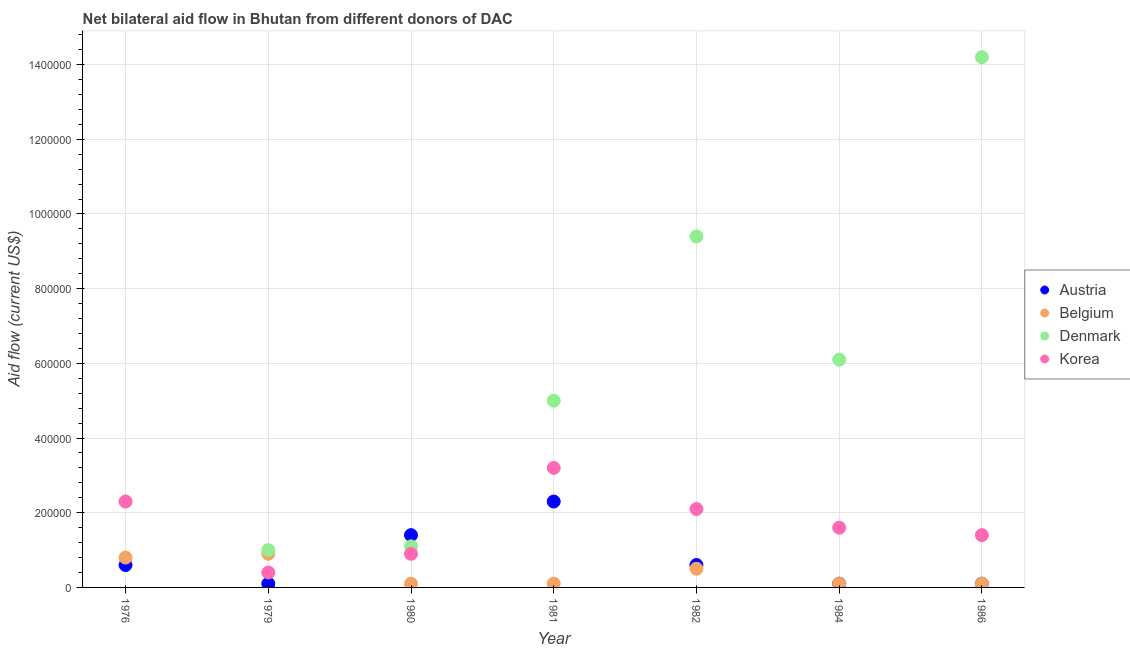How many different coloured dotlines are there?
Keep it short and to the point. 4. What is the amount of aid given by korea in 1984?
Make the answer very short. 1.60e+05. Across all years, what is the maximum amount of aid given by austria?
Give a very brief answer. 2.30e+05. Across all years, what is the minimum amount of aid given by denmark?
Provide a short and direct response. 1.00e+05. In which year was the amount of aid given by denmark maximum?
Give a very brief answer. 1986. In which year was the amount of aid given by korea minimum?
Offer a very short reply. 1979. What is the total amount of aid given by austria in the graph?
Offer a terse response. 5.20e+05. What is the difference between the amount of aid given by korea in 1980 and that in 1986?
Your answer should be very brief. -5.00e+04. What is the difference between the amount of aid given by belgium in 1979 and the amount of aid given by korea in 1984?
Offer a terse response. -7.00e+04. What is the average amount of aid given by belgium per year?
Provide a short and direct response. 3.71e+04. In the year 1986, what is the difference between the amount of aid given by denmark and amount of aid given by belgium?
Give a very brief answer. 1.41e+06. In how many years, is the amount of aid given by austria greater than 1200000 US$?
Ensure brevity in your answer.  0. What is the ratio of the amount of aid given by belgium in 1976 to that in 1979?
Offer a very short reply. 0.89. Is the amount of aid given by korea in 1976 less than that in 1981?
Provide a short and direct response. Yes. What is the difference between the highest and the lowest amount of aid given by denmark?
Your answer should be very brief. 1.32e+06. In how many years, is the amount of aid given by denmark greater than the average amount of aid given by denmark taken over all years?
Offer a terse response. 3. Is the sum of the amount of aid given by denmark in 1976 and 1981 greater than the maximum amount of aid given by korea across all years?
Keep it short and to the point. Yes. Does the amount of aid given by denmark monotonically increase over the years?
Provide a short and direct response. No. Is the amount of aid given by austria strictly greater than the amount of aid given by denmark over the years?
Offer a terse response. No. Is the amount of aid given by austria strictly less than the amount of aid given by korea over the years?
Provide a succinct answer. No. How many dotlines are there?
Your response must be concise. 4. How many years are there in the graph?
Your response must be concise. 7. Does the graph contain any zero values?
Your answer should be very brief. No. Does the graph contain grids?
Provide a short and direct response. Yes. Where does the legend appear in the graph?
Make the answer very short. Center right. What is the title of the graph?
Keep it short and to the point. Net bilateral aid flow in Bhutan from different donors of DAC. Does "Financial sector" appear as one of the legend labels in the graph?
Your response must be concise. No. What is the Aid flow (current US$) in Belgium in 1976?
Give a very brief answer. 8.00e+04. What is the Aid flow (current US$) in Denmark in 1976?
Your response must be concise. 2.30e+05. What is the Aid flow (current US$) in Korea in 1979?
Your response must be concise. 4.00e+04. What is the Aid flow (current US$) of Denmark in 1980?
Ensure brevity in your answer.  1.10e+05. What is the Aid flow (current US$) of Austria in 1981?
Your answer should be compact. 2.30e+05. What is the Aid flow (current US$) in Denmark in 1981?
Provide a short and direct response. 5.00e+05. What is the Aid flow (current US$) of Belgium in 1982?
Your answer should be very brief. 5.00e+04. What is the Aid flow (current US$) of Denmark in 1982?
Make the answer very short. 9.40e+05. What is the Aid flow (current US$) in Korea in 1982?
Ensure brevity in your answer.  2.10e+05. What is the Aid flow (current US$) of Austria in 1984?
Make the answer very short. 10000. What is the Aid flow (current US$) of Belgium in 1986?
Your response must be concise. 10000. What is the Aid flow (current US$) in Denmark in 1986?
Offer a terse response. 1.42e+06. Across all years, what is the maximum Aid flow (current US$) of Belgium?
Your answer should be very brief. 9.00e+04. Across all years, what is the maximum Aid flow (current US$) in Denmark?
Make the answer very short. 1.42e+06. Across all years, what is the maximum Aid flow (current US$) of Korea?
Your answer should be very brief. 3.20e+05. Across all years, what is the minimum Aid flow (current US$) of Korea?
Make the answer very short. 4.00e+04. What is the total Aid flow (current US$) in Austria in the graph?
Offer a very short reply. 5.20e+05. What is the total Aid flow (current US$) of Belgium in the graph?
Your response must be concise. 2.60e+05. What is the total Aid flow (current US$) in Denmark in the graph?
Provide a short and direct response. 3.91e+06. What is the total Aid flow (current US$) in Korea in the graph?
Your answer should be very brief. 1.19e+06. What is the difference between the Aid flow (current US$) of Belgium in 1976 and that in 1980?
Your response must be concise. 7.00e+04. What is the difference between the Aid flow (current US$) of Korea in 1976 and that in 1980?
Give a very brief answer. 1.40e+05. What is the difference between the Aid flow (current US$) in Austria in 1976 and that in 1981?
Offer a terse response. -1.70e+05. What is the difference between the Aid flow (current US$) of Denmark in 1976 and that in 1981?
Ensure brevity in your answer.  -2.70e+05. What is the difference between the Aid flow (current US$) of Denmark in 1976 and that in 1982?
Ensure brevity in your answer.  -7.10e+05. What is the difference between the Aid flow (current US$) in Austria in 1976 and that in 1984?
Provide a short and direct response. 5.00e+04. What is the difference between the Aid flow (current US$) of Belgium in 1976 and that in 1984?
Make the answer very short. 7.00e+04. What is the difference between the Aid flow (current US$) of Denmark in 1976 and that in 1984?
Ensure brevity in your answer.  -3.80e+05. What is the difference between the Aid flow (current US$) of Denmark in 1976 and that in 1986?
Offer a terse response. -1.19e+06. What is the difference between the Aid flow (current US$) of Korea in 1976 and that in 1986?
Give a very brief answer. 9.00e+04. What is the difference between the Aid flow (current US$) of Denmark in 1979 and that in 1980?
Offer a very short reply. -10000. What is the difference between the Aid flow (current US$) in Belgium in 1979 and that in 1981?
Your response must be concise. 8.00e+04. What is the difference between the Aid flow (current US$) of Denmark in 1979 and that in 1981?
Offer a terse response. -4.00e+05. What is the difference between the Aid flow (current US$) of Korea in 1979 and that in 1981?
Provide a succinct answer. -2.80e+05. What is the difference between the Aid flow (current US$) in Denmark in 1979 and that in 1982?
Provide a short and direct response. -8.40e+05. What is the difference between the Aid flow (current US$) in Denmark in 1979 and that in 1984?
Give a very brief answer. -5.10e+05. What is the difference between the Aid flow (current US$) in Korea in 1979 and that in 1984?
Make the answer very short. -1.20e+05. What is the difference between the Aid flow (current US$) of Denmark in 1979 and that in 1986?
Give a very brief answer. -1.32e+06. What is the difference between the Aid flow (current US$) of Korea in 1979 and that in 1986?
Your answer should be compact. -1.00e+05. What is the difference between the Aid flow (current US$) of Austria in 1980 and that in 1981?
Keep it short and to the point. -9.00e+04. What is the difference between the Aid flow (current US$) in Belgium in 1980 and that in 1981?
Your answer should be very brief. 0. What is the difference between the Aid flow (current US$) in Denmark in 1980 and that in 1981?
Make the answer very short. -3.90e+05. What is the difference between the Aid flow (current US$) of Belgium in 1980 and that in 1982?
Your response must be concise. -4.00e+04. What is the difference between the Aid flow (current US$) in Denmark in 1980 and that in 1982?
Provide a short and direct response. -8.30e+05. What is the difference between the Aid flow (current US$) of Austria in 1980 and that in 1984?
Your answer should be very brief. 1.30e+05. What is the difference between the Aid flow (current US$) of Belgium in 1980 and that in 1984?
Provide a succinct answer. 0. What is the difference between the Aid flow (current US$) of Denmark in 1980 and that in 1984?
Offer a very short reply. -5.00e+05. What is the difference between the Aid flow (current US$) in Austria in 1980 and that in 1986?
Keep it short and to the point. 1.30e+05. What is the difference between the Aid flow (current US$) of Belgium in 1980 and that in 1986?
Give a very brief answer. 0. What is the difference between the Aid flow (current US$) in Denmark in 1980 and that in 1986?
Give a very brief answer. -1.31e+06. What is the difference between the Aid flow (current US$) in Belgium in 1981 and that in 1982?
Your response must be concise. -4.00e+04. What is the difference between the Aid flow (current US$) of Denmark in 1981 and that in 1982?
Your answer should be very brief. -4.40e+05. What is the difference between the Aid flow (current US$) of Korea in 1981 and that in 1982?
Offer a terse response. 1.10e+05. What is the difference between the Aid flow (current US$) of Austria in 1981 and that in 1984?
Provide a succinct answer. 2.20e+05. What is the difference between the Aid flow (current US$) of Belgium in 1981 and that in 1984?
Offer a terse response. 0. What is the difference between the Aid flow (current US$) of Denmark in 1981 and that in 1984?
Your answer should be very brief. -1.10e+05. What is the difference between the Aid flow (current US$) in Korea in 1981 and that in 1984?
Offer a terse response. 1.60e+05. What is the difference between the Aid flow (current US$) of Austria in 1981 and that in 1986?
Give a very brief answer. 2.20e+05. What is the difference between the Aid flow (current US$) in Denmark in 1981 and that in 1986?
Provide a short and direct response. -9.20e+05. What is the difference between the Aid flow (current US$) in Korea in 1981 and that in 1986?
Provide a short and direct response. 1.80e+05. What is the difference between the Aid flow (current US$) of Austria in 1982 and that in 1984?
Your answer should be very brief. 5.00e+04. What is the difference between the Aid flow (current US$) of Belgium in 1982 and that in 1984?
Your answer should be compact. 4.00e+04. What is the difference between the Aid flow (current US$) in Denmark in 1982 and that in 1984?
Ensure brevity in your answer.  3.30e+05. What is the difference between the Aid flow (current US$) in Austria in 1982 and that in 1986?
Offer a terse response. 5.00e+04. What is the difference between the Aid flow (current US$) of Belgium in 1982 and that in 1986?
Your answer should be compact. 4.00e+04. What is the difference between the Aid flow (current US$) in Denmark in 1982 and that in 1986?
Your answer should be very brief. -4.80e+05. What is the difference between the Aid flow (current US$) in Korea in 1982 and that in 1986?
Your answer should be compact. 7.00e+04. What is the difference between the Aid flow (current US$) of Belgium in 1984 and that in 1986?
Your answer should be compact. 0. What is the difference between the Aid flow (current US$) in Denmark in 1984 and that in 1986?
Provide a short and direct response. -8.10e+05. What is the difference between the Aid flow (current US$) in Korea in 1984 and that in 1986?
Your answer should be very brief. 2.00e+04. What is the difference between the Aid flow (current US$) in Austria in 1976 and the Aid flow (current US$) in Korea in 1979?
Ensure brevity in your answer.  2.00e+04. What is the difference between the Aid flow (current US$) in Belgium in 1976 and the Aid flow (current US$) in Korea in 1979?
Your response must be concise. 4.00e+04. What is the difference between the Aid flow (current US$) of Denmark in 1976 and the Aid flow (current US$) of Korea in 1979?
Your response must be concise. 1.90e+05. What is the difference between the Aid flow (current US$) in Austria in 1976 and the Aid flow (current US$) in Korea in 1980?
Keep it short and to the point. -3.00e+04. What is the difference between the Aid flow (current US$) in Belgium in 1976 and the Aid flow (current US$) in Denmark in 1980?
Your answer should be very brief. -3.00e+04. What is the difference between the Aid flow (current US$) of Belgium in 1976 and the Aid flow (current US$) of Korea in 1980?
Ensure brevity in your answer.  -10000. What is the difference between the Aid flow (current US$) in Austria in 1976 and the Aid flow (current US$) in Denmark in 1981?
Give a very brief answer. -4.40e+05. What is the difference between the Aid flow (current US$) in Austria in 1976 and the Aid flow (current US$) in Korea in 1981?
Give a very brief answer. -2.60e+05. What is the difference between the Aid flow (current US$) in Belgium in 1976 and the Aid flow (current US$) in Denmark in 1981?
Make the answer very short. -4.20e+05. What is the difference between the Aid flow (current US$) of Austria in 1976 and the Aid flow (current US$) of Belgium in 1982?
Your answer should be compact. 10000. What is the difference between the Aid flow (current US$) in Austria in 1976 and the Aid flow (current US$) in Denmark in 1982?
Your answer should be very brief. -8.80e+05. What is the difference between the Aid flow (current US$) of Belgium in 1976 and the Aid flow (current US$) of Denmark in 1982?
Your response must be concise. -8.60e+05. What is the difference between the Aid flow (current US$) in Belgium in 1976 and the Aid flow (current US$) in Korea in 1982?
Give a very brief answer. -1.30e+05. What is the difference between the Aid flow (current US$) of Austria in 1976 and the Aid flow (current US$) of Denmark in 1984?
Offer a very short reply. -5.50e+05. What is the difference between the Aid flow (current US$) of Belgium in 1976 and the Aid flow (current US$) of Denmark in 1984?
Your answer should be compact. -5.30e+05. What is the difference between the Aid flow (current US$) in Denmark in 1976 and the Aid flow (current US$) in Korea in 1984?
Keep it short and to the point. 7.00e+04. What is the difference between the Aid flow (current US$) in Austria in 1976 and the Aid flow (current US$) in Denmark in 1986?
Offer a terse response. -1.36e+06. What is the difference between the Aid flow (current US$) in Austria in 1976 and the Aid flow (current US$) in Korea in 1986?
Offer a very short reply. -8.00e+04. What is the difference between the Aid flow (current US$) of Belgium in 1976 and the Aid flow (current US$) of Denmark in 1986?
Offer a very short reply. -1.34e+06. What is the difference between the Aid flow (current US$) of Belgium in 1976 and the Aid flow (current US$) of Korea in 1986?
Provide a succinct answer. -6.00e+04. What is the difference between the Aid flow (current US$) in Denmark in 1976 and the Aid flow (current US$) in Korea in 1986?
Give a very brief answer. 9.00e+04. What is the difference between the Aid flow (current US$) of Austria in 1979 and the Aid flow (current US$) of Belgium in 1980?
Keep it short and to the point. 0. What is the difference between the Aid flow (current US$) in Austria in 1979 and the Aid flow (current US$) in Denmark in 1981?
Keep it short and to the point. -4.90e+05. What is the difference between the Aid flow (current US$) in Austria in 1979 and the Aid flow (current US$) in Korea in 1981?
Give a very brief answer. -3.10e+05. What is the difference between the Aid flow (current US$) in Belgium in 1979 and the Aid flow (current US$) in Denmark in 1981?
Provide a succinct answer. -4.10e+05. What is the difference between the Aid flow (current US$) in Belgium in 1979 and the Aid flow (current US$) in Korea in 1981?
Your answer should be compact. -2.30e+05. What is the difference between the Aid flow (current US$) in Austria in 1979 and the Aid flow (current US$) in Denmark in 1982?
Ensure brevity in your answer.  -9.30e+05. What is the difference between the Aid flow (current US$) in Austria in 1979 and the Aid flow (current US$) in Korea in 1982?
Provide a short and direct response. -2.00e+05. What is the difference between the Aid flow (current US$) of Belgium in 1979 and the Aid flow (current US$) of Denmark in 1982?
Offer a very short reply. -8.50e+05. What is the difference between the Aid flow (current US$) of Belgium in 1979 and the Aid flow (current US$) of Korea in 1982?
Offer a very short reply. -1.20e+05. What is the difference between the Aid flow (current US$) of Denmark in 1979 and the Aid flow (current US$) of Korea in 1982?
Offer a terse response. -1.10e+05. What is the difference between the Aid flow (current US$) in Austria in 1979 and the Aid flow (current US$) in Denmark in 1984?
Offer a very short reply. -6.00e+05. What is the difference between the Aid flow (current US$) of Austria in 1979 and the Aid flow (current US$) of Korea in 1984?
Offer a very short reply. -1.50e+05. What is the difference between the Aid flow (current US$) in Belgium in 1979 and the Aid flow (current US$) in Denmark in 1984?
Offer a very short reply. -5.20e+05. What is the difference between the Aid flow (current US$) in Denmark in 1979 and the Aid flow (current US$) in Korea in 1984?
Make the answer very short. -6.00e+04. What is the difference between the Aid flow (current US$) in Austria in 1979 and the Aid flow (current US$) in Belgium in 1986?
Provide a succinct answer. 0. What is the difference between the Aid flow (current US$) in Austria in 1979 and the Aid flow (current US$) in Denmark in 1986?
Ensure brevity in your answer.  -1.41e+06. What is the difference between the Aid flow (current US$) of Austria in 1979 and the Aid flow (current US$) of Korea in 1986?
Your response must be concise. -1.30e+05. What is the difference between the Aid flow (current US$) in Belgium in 1979 and the Aid flow (current US$) in Denmark in 1986?
Provide a short and direct response. -1.33e+06. What is the difference between the Aid flow (current US$) of Belgium in 1979 and the Aid flow (current US$) of Korea in 1986?
Your answer should be compact. -5.00e+04. What is the difference between the Aid flow (current US$) in Austria in 1980 and the Aid flow (current US$) in Denmark in 1981?
Your answer should be very brief. -3.60e+05. What is the difference between the Aid flow (current US$) in Belgium in 1980 and the Aid flow (current US$) in Denmark in 1981?
Your response must be concise. -4.90e+05. What is the difference between the Aid flow (current US$) of Belgium in 1980 and the Aid flow (current US$) of Korea in 1981?
Provide a short and direct response. -3.10e+05. What is the difference between the Aid flow (current US$) in Austria in 1980 and the Aid flow (current US$) in Denmark in 1982?
Provide a short and direct response. -8.00e+05. What is the difference between the Aid flow (current US$) of Austria in 1980 and the Aid flow (current US$) of Korea in 1982?
Keep it short and to the point. -7.00e+04. What is the difference between the Aid flow (current US$) of Belgium in 1980 and the Aid flow (current US$) of Denmark in 1982?
Give a very brief answer. -9.30e+05. What is the difference between the Aid flow (current US$) in Belgium in 1980 and the Aid flow (current US$) in Korea in 1982?
Your response must be concise. -2.00e+05. What is the difference between the Aid flow (current US$) of Denmark in 1980 and the Aid flow (current US$) of Korea in 1982?
Give a very brief answer. -1.00e+05. What is the difference between the Aid flow (current US$) in Austria in 1980 and the Aid flow (current US$) in Denmark in 1984?
Your answer should be very brief. -4.70e+05. What is the difference between the Aid flow (current US$) of Belgium in 1980 and the Aid flow (current US$) of Denmark in 1984?
Your answer should be compact. -6.00e+05. What is the difference between the Aid flow (current US$) of Denmark in 1980 and the Aid flow (current US$) of Korea in 1984?
Offer a terse response. -5.00e+04. What is the difference between the Aid flow (current US$) of Austria in 1980 and the Aid flow (current US$) of Belgium in 1986?
Make the answer very short. 1.30e+05. What is the difference between the Aid flow (current US$) of Austria in 1980 and the Aid flow (current US$) of Denmark in 1986?
Offer a terse response. -1.28e+06. What is the difference between the Aid flow (current US$) in Belgium in 1980 and the Aid flow (current US$) in Denmark in 1986?
Offer a very short reply. -1.41e+06. What is the difference between the Aid flow (current US$) of Belgium in 1980 and the Aid flow (current US$) of Korea in 1986?
Your answer should be very brief. -1.30e+05. What is the difference between the Aid flow (current US$) of Austria in 1981 and the Aid flow (current US$) of Belgium in 1982?
Your answer should be very brief. 1.80e+05. What is the difference between the Aid flow (current US$) of Austria in 1981 and the Aid flow (current US$) of Denmark in 1982?
Provide a short and direct response. -7.10e+05. What is the difference between the Aid flow (current US$) of Austria in 1981 and the Aid flow (current US$) of Korea in 1982?
Offer a terse response. 2.00e+04. What is the difference between the Aid flow (current US$) of Belgium in 1981 and the Aid flow (current US$) of Denmark in 1982?
Keep it short and to the point. -9.30e+05. What is the difference between the Aid flow (current US$) of Belgium in 1981 and the Aid flow (current US$) of Korea in 1982?
Your response must be concise. -2.00e+05. What is the difference between the Aid flow (current US$) in Austria in 1981 and the Aid flow (current US$) in Denmark in 1984?
Make the answer very short. -3.80e+05. What is the difference between the Aid flow (current US$) in Austria in 1981 and the Aid flow (current US$) in Korea in 1984?
Provide a succinct answer. 7.00e+04. What is the difference between the Aid flow (current US$) in Belgium in 1981 and the Aid flow (current US$) in Denmark in 1984?
Ensure brevity in your answer.  -6.00e+05. What is the difference between the Aid flow (current US$) in Belgium in 1981 and the Aid flow (current US$) in Korea in 1984?
Provide a short and direct response. -1.50e+05. What is the difference between the Aid flow (current US$) of Denmark in 1981 and the Aid flow (current US$) of Korea in 1984?
Offer a terse response. 3.40e+05. What is the difference between the Aid flow (current US$) in Austria in 1981 and the Aid flow (current US$) in Denmark in 1986?
Make the answer very short. -1.19e+06. What is the difference between the Aid flow (current US$) of Austria in 1981 and the Aid flow (current US$) of Korea in 1986?
Your answer should be compact. 9.00e+04. What is the difference between the Aid flow (current US$) of Belgium in 1981 and the Aid flow (current US$) of Denmark in 1986?
Offer a terse response. -1.41e+06. What is the difference between the Aid flow (current US$) of Austria in 1982 and the Aid flow (current US$) of Denmark in 1984?
Offer a terse response. -5.50e+05. What is the difference between the Aid flow (current US$) of Belgium in 1982 and the Aid flow (current US$) of Denmark in 1984?
Offer a terse response. -5.60e+05. What is the difference between the Aid flow (current US$) in Belgium in 1982 and the Aid flow (current US$) in Korea in 1984?
Provide a short and direct response. -1.10e+05. What is the difference between the Aid flow (current US$) of Denmark in 1982 and the Aid flow (current US$) of Korea in 1984?
Keep it short and to the point. 7.80e+05. What is the difference between the Aid flow (current US$) of Austria in 1982 and the Aid flow (current US$) of Belgium in 1986?
Provide a succinct answer. 5.00e+04. What is the difference between the Aid flow (current US$) of Austria in 1982 and the Aid flow (current US$) of Denmark in 1986?
Make the answer very short. -1.36e+06. What is the difference between the Aid flow (current US$) of Austria in 1982 and the Aid flow (current US$) of Korea in 1986?
Your answer should be very brief. -8.00e+04. What is the difference between the Aid flow (current US$) of Belgium in 1982 and the Aid flow (current US$) of Denmark in 1986?
Your answer should be compact. -1.37e+06. What is the difference between the Aid flow (current US$) in Denmark in 1982 and the Aid flow (current US$) in Korea in 1986?
Your response must be concise. 8.00e+05. What is the difference between the Aid flow (current US$) in Austria in 1984 and the Aid flow (current US$) in Belgium in 1986?
Your response must be concise. 0. What is the difference between the Aid flow (current US$) in Austria in 1984 and the Aid flow (current US$) in Denmark in 1986?
Keep it short and to the point. -1.41e+06. What is the difference between the Aid flow (current US$) in Belgium in 1984 and the Aid flow (current US$) in Denmark in 1986?
Make the answer very short. -1.41e+06. What is the difference between the Aid flow (current US$) in Belgium in 1984 and the Aid flow (current US$) in Korea in 1986?
Keep it short and to the point. -1.30e+05. What is the difference between the Aid flow (current US$) in Denmark in 1984 and the Aid flow (current US$) in Korea in 1986?
Your answer should be very brief. 4.70e+05. What is the average Aid flow (current US$) in Austria per year?
Make the answer very short. 7.43e+04. What is the average Aid flow (current US$) in Belgium per year?
Your answer should be compact. 3.71e+04. What is the average Aid flow (current US$) of Denmark per year?
Your response must be concise. 5.59e+05. What is the average Aid flow (current US$) in Korea per year?
Offer a terse response. 1.70e+05. In the year 1976, what is the difference between the Aid flow (current US$) in Austria and Aid flow (current US$) in Denmark?
Your answer should be compact. -1.70e+05. In the year 1976, what is the difference between the Aid flow (current US$) of Austria and Aid flow (current US$) of Korea?
Your response must be concise. -1.70e+05. In the year 1976, what is the difference between the Aid flow (current US$) of Belgium and Aid flow (current US$) of Denmark?
Your response must be concise. -1.50e+05. In the year 1976, what is the difference between the Aid flow (current US$) in Denmark and Aid flow (current US$) in Korea?
Offer a terse response. 0. In the year 1979, what is the difference between the Aid flow (current US$) in Austria and Aid flow (current US$) in Belgium?
Keep it short and to the point. -8.00e+04. In the year 1979, what is the difference between the Aid flow (current US$) in Denmark and Aid flow (current US$) in Korea?
Your response must be concise. 6.00e+04. In the year 1980, what is the difference between the Aid flow (current US$) of Austria and Aid flow (current US$) of Denmark?
Give a very brief answer. 3.00e+04. In the year 1980, what is the difference between the Aid flow (current US$) of Austria and Aid flow (current US$) of Korea?
Make the answer very short. 5.00e+04. In the year 1980, what is the difference between the Aid flow (current US$) of Belgium and Aid flow (current US$) of Korea?
Offer a terse response. -8.00e+04. In the year 1981, what is the difference between the Aid flow (current US$) in Austria and Aid flow (current US$) in Belgium?
Provide a succinct answer. 2.20e+05. In the year 1981, what is the difference between the Aid flow (current US$) in Austria and Aid flow (current US$) in Denmark?
Provide a succinct answer. -2.70e+05. In the year 1981, what is the difference between the Aid flow (current US$) of Belgium and Aid flow (current US$) of Denmark?
Offer a terse response. -4.90e+05. In the year 1981, what is the difference between the Aid flow (current US$) in Belgium and Aid flow (current US$) in Korea?
Offer a terse response. -3.10e+05. In the year 1982, what is the difference between the Aid flow (current US$) of Austria and Aid flow (current US$) of Denmark?
Your response must be concise. -8.80e+05. In the year 1982, what is the difference between the Aid flow (current US$) in Belgium and Aid flow (current US$) in Denmark?
Offer a terse response. -8.90e+05. In the year 1982, what is the difference between the Aid flow (current US$) of Belgium and Aid flow (current US$) of Korea?
Give a very brief answer. -1.60e+05. In the year 1982, what is the difference between the Aid flow (current US$) in Denmark and Aid flow (current US$) in Korea?
Offer a terse response. 7.30e+05. In the year 1984, what is the difference between the Aid flow (current US$) of Austria and Aid flow (current US$) of Belgium?
Keep it short and to the point. 0. In the year 1984, what is the difference between the Aid flow (current US$) in Austria and Aid flow (current US$) in Denmark?
Provide a succinct answer. -6.00e+05. In the year 1984, what is the difference between the Aid flow (current US$) of Belgium and Aid flow (current US$) of Denmark?
Give a very brief answer. -6.00e+05. In the year 1984, what is the difference between the Aid flow (current US$) of Denmark and Aid flow (current US$) of Korea?
Ensure brevity in your answer.  4.50e+05. In the year 1986, what is the difference between the Aid flow (current US$) of Austria and Aid flow (current US$) of Belgium?
Your answer should be very brief. 0. In the year 1986, what is the difference between the Aid flow (current US$) in Austria and Aid flow (current US$) in Denmark?
Keep it short and to the point. -1.41e+06. In the year 1986, what is the difference between the Aid flow (current US$) of Austria and Aid flow (current US$) of Korea?
Make the answer very short. -1.30e+05. In the year 1986, what is the difference between the Aid flow (current US$) in Belgium and Aid flow (current US$) in Denmark?
Provide a short and direct response. -1.41e+06. In the year 1986, what is the difference between the Aid flow (current US$) in Belgium and Aid flow (current US$) in Korea?
Keep it short and to the point. -1.30e+05. In the year 1986, what is the difference between the Aid flow (current US$) of Denmark and Aid flow (current US$) of Korea?
Offer a terse response. 1.28e+06. What is the ratio of the Aid flow (current US$) in Austria in 1976 to that in 1979?
Offer a terse response. 6. What is the ratio of the Aid flow (current US$) in Korea in 1976 to that in 1979?
Ensure brevity in your answer.  5.75. What is the ratio of the Aid flow (current US$) of Austria in 1976 to that in 1980?
Provide a short and direct response. 0.43. What is the ratio of the Aid flow (current US$) of Denmark in 1976 to that in 1980?
Offer a terse response. 2.09. What is the ratio of the Aid flow (current US$) of Korea in 1976 to that in 1980?
Offer a terse response. 2.56. What is the ratio of the Aid flow (current US$) of Austria in 1976 to that in 1981?
Provide a succinct answer. 0.26. What is the ratio of the Aid flow (current US$) of Denmark in 1976 to that in 1981?
Make the answer very short. 0.46. What is the ratio of the Aid flow (current US$) in Korea in 1976 to that in 1981?
Keep it short and to the point. 0.72. What is the ratio of the Aid flow (current US$) in Belgium in 1976 to that in 1982?
Give a very brief answer. 1.6. What is the ratio of the Aid flow (current US$) in Denmark in 1976 to that in 1982?
Your answer should be compact. 0.24. What is the ratio of the Aid flow (current US$) in Korea in 1976 to that in 1982?
Your response must be concise. 1.1. What is the ratio of the Aid flow (current US$) in Austria in 1976 to that in 1984?
Offer a very short reply. 6. What is the ratio of the Aid flow (current US$) of Denmark in 1976 to that in 1984?
Provide a short and direct response. 0.38. What is the ratio of the Aid flow (current US$) of Korea in 1976 to that in 1984?
Offer a very short reply. 1.44. What is the ratio of the Aid flow (current US$) in Denmark in 1976 to that in 1986?
Your answer should be very brief. 0.16. What is the ratio of the Aid flow (current US$) in Korea in 1976 to that in 1986?
Offer a terse response. 1.64. What is the ratio of the Aid flow (current US$) of Austria in 1979 to that in 1980?
Provide a succinct answer. 0.07. What is the ratio of the Aid flow (current US$) of Korea in 1979 to that in 1980?
Give a very brief answer. 0.44. What is the ratio of the Aid flow (current US$) of Austria in 1979 to that in 1981?
Ensure brevity in your answer.  0.04. What is the ratio of the Aid flow (current US$) of Austria in 1979 to that in 1982?
Provide a short and direct response. 0.17. What is the ratio of the Aid flow (current US$) in Belgium in 1979 to that in 1982?
Give a very brief answer. 1.8. What is the ratio of the Aid flow (current US$) in Denmark in 1979 to that in 1982?
Your response must be concise. 0.11. What is the ratio of the Aid flow (current US$) in Korea in 1979 to that in 1982?
Your answer should be compact. 0.19. What is the ratio of the Aid flow (current US$) of Austria in 1979 to that in 1984?
Offer a terse response. 1. What is the ratio of the Aid flow (current US$) of Denmark in 1979 to that in 1984?
Give a very brief answer. 0.16. What is the ratio of the Aid flow (current US$) in Belgium in 1979 to that in 1986?
Provide a succinct answer. 9. What is the ratio of the Aid flow (current US$) of Denmark in 1979 to that in 1986?
Give a very brief answer. 0.07. What is the ratio of the Aid flow (current US$) of Korea in 1979 to that in 1986?
Offer a very short reply. 0.29. What is the ratio of the Aid flow (current US$) in Austria in 1980 to that in 1981?
Your response must be concise. 0.61. What is the ratio of the Aid flow (current US$) in Denmark in 1980 to that in 1981?
Give a very brief answer. 0.22. What is the ratio of the Aid flow (current US$) in Korea in 1980 to that in 1981?
Keep it short and to the point. 0.28. What is the ratio of the Aid flow (current US$) of Austria in 1980 to that in 1982?
Ensure brevity in your answer.  2.33. What is the ratio of the Aid flow (current US$) of Belgium in 1980 to that in 1982?
Ensure brevity in your answer.  0.2. What is the ratio of the Aid flow (current US$) of Denmark in 1980 to that in 1982?
Keep it short and to the point. 0.12. What is the ratio of the Aid flow (current US$) of Korea in 1980 to that in 1982?
Your answer should be very brief. 0.43. What is the ratio of the Aid flow (current US$) in Denmark in 1980 to that in 1984?
Your answer should be very brief. 0.18. What is the ratio of the Aid flow (current US$) of Korea in 1980 to that in 1984?
Keep it short and to the point. 0.56. What is the ratio of the Aid flow (current US$) in Belgium in 1980 to that in 1986?
Ensure brevity in your answer.  1. What is the ratio of the Aid flow (current US$) in Denmark in 1980 to that in 1986?
Offer a terse response. 0.08. What is the ratio of the Aid flow (current US$) in Korea in 1980 to that in 1986?
Ensure brevity in your answer.  0.64. What is the ratio of the Aid flow (current US$) in Austria in 1981 to that in 1982?
Give a very brief answer. 3.83. What is the ratio of the Aid flow (current US$) in Denmark in 1981 to that in 1982?
Your answer should be compact. 0.53. What is the ratio of the Aid flow (current US$) of Korea in 1981 to that in 1982?
Your response must be concise. 1.52. What is the ratio of the Aid flow (current US$) of Denmark in 1981 to that in 1984?
Offer a very short reply. 0.82. What is the ratio of the Aid flow (current US$) of Denmark in 1981 to that in 1986?
Give a very brief answer. 0.35. What is the ratio of the Aid flow (current US$) in Korea in 1981 to that in 1986?
Keep it short and to the point. 2.29. What is the ratio of the Aid flow (current US$) of Austria in 1982 to that in 1984?
Provide a succinct answer. 6. What is the ratio of the Aid flow (current US$) of Denmark in 1982 to that in 1984?
Provide a short and direct response. 1.54. What is the ratio of the Aid flow (current US$) of Korea in 1982 to that in 1984?
Your response must be concise. 1.31. What is the ratio of the Aid flow (current US$) of Denmark in 1982 to that in 1986?
Offer a very short reply. 0.66. What is the ratio of the Aid flow (current US$) of Denmark in 1984 to that in 1986?
Provide a succinct answer. 0.43. What is the difference between the highest and the second highest Aid flow (current US$) of Denmark?
Your answer should be compact. 4.80e+05. What is the difference between the highest and the second highest Aid flow (current US$) of Korea?
Give a very brief answer. 9.00e+04. What is the difference between the highest and the lowest Aid flow (current US$) in Belgium?
Provide a succinct answer. 8.00e+04. What is the difference between the highest and the lowest Aid flow (current US$) in Denmark?
Keep it short and to the point. 1.32e+06. 